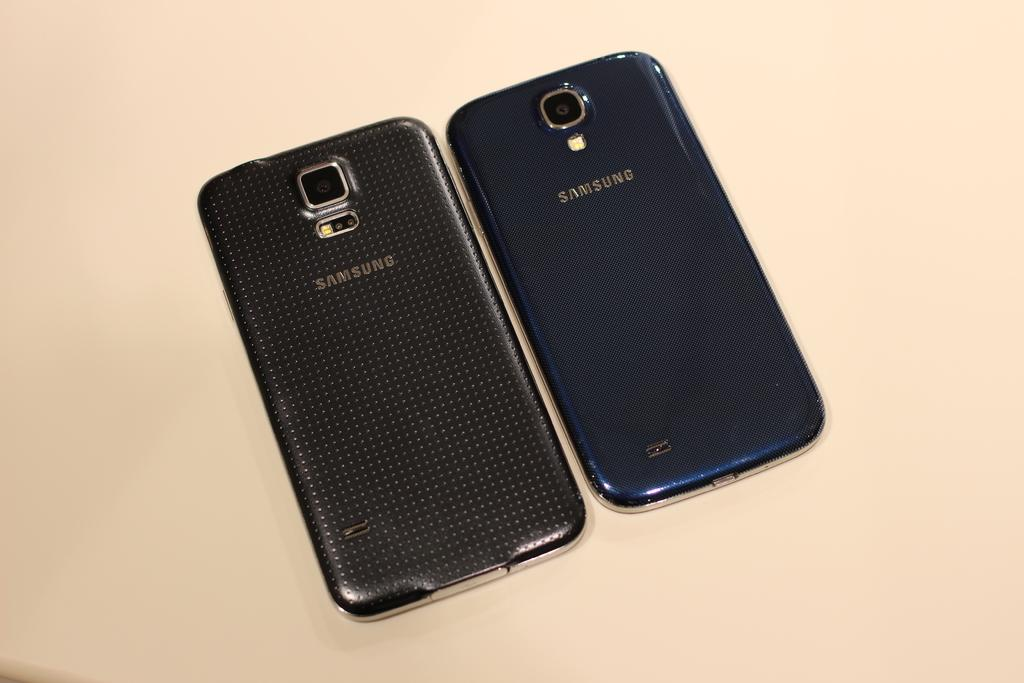<image>
Present a compact description of the photo's key features. Two samsung cellphones are on the table, both are face down. 